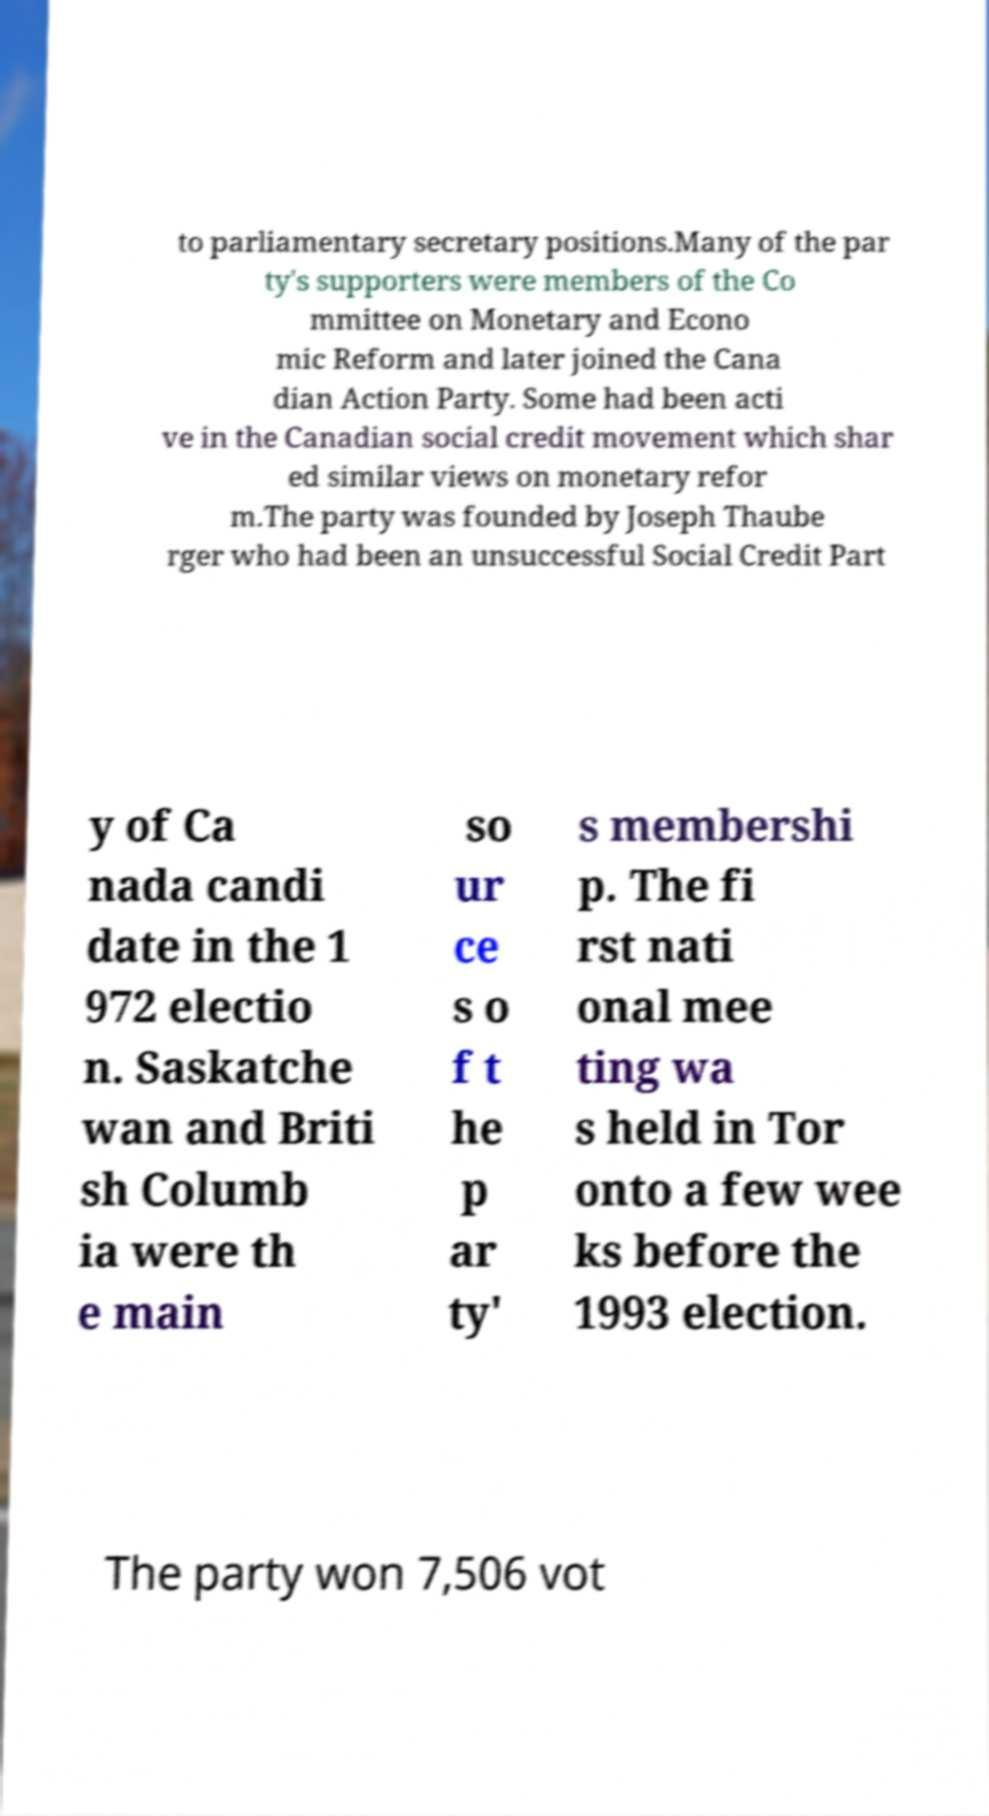Can you accurately transcribe the text from the provided image for me? to parliamentary secretary positions.Many of the par ty's supporters were members of the Co mmittee on Monetary and Econo mic Reform and later joined the Cana dian Action Party. Some had been acti ve in the Canadian social credit movement which shar ed similar views on monetary refor m.The party was founded by Joseph Thaube rger who had been an unsuccessful Social Credit Part y of Ca nada candi date in the 1 972 electio n. Saskatche wan and Briti sh Columb ia were th e main so ur ce s o f t he p ar ty' s membershi p. The fi rst nati onal mee ting wa s held in Tor onto a few wee ks before the 1993 election. The party won 7,506 vot 